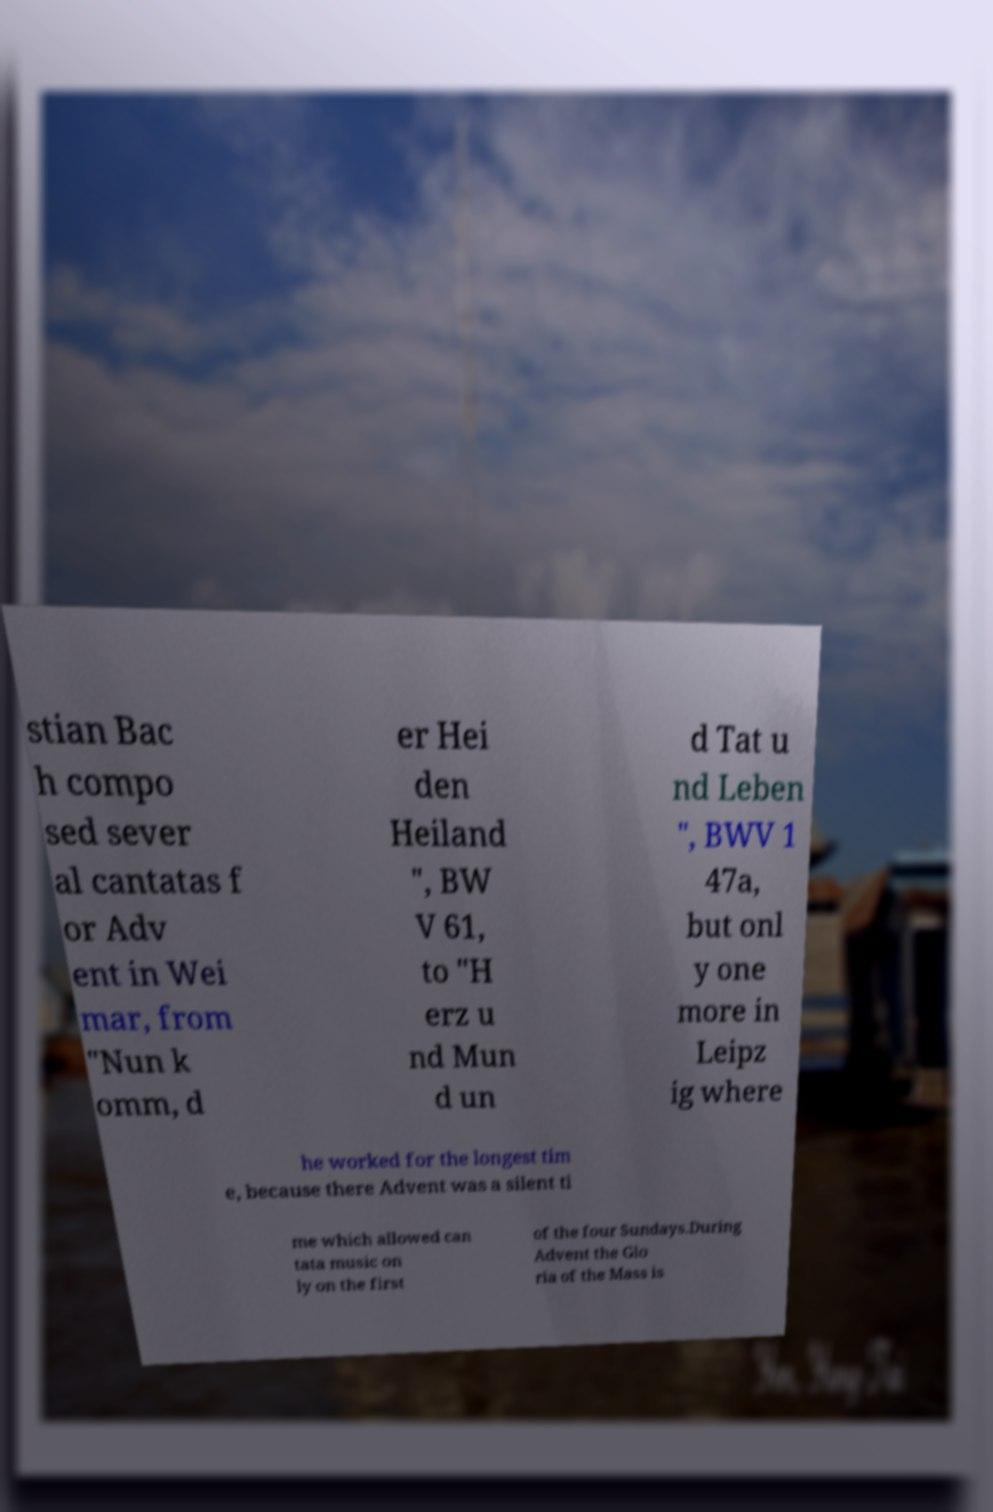Please read and relay the text visible in this image. What does it say? stian Bac h compo sed sever al cantatas f or Adv ent in Wei mar, from "Nun k omm, d er Hei den Heiland ", BW V 61, to "H erz u nd Mun d un d Tat u nd Leben ", BWV 1 47a, but onl y one more in Leipz ig where he worked for the longest tim e, because there Advent was a silent ti me which allowed can tata music on ly on the first of the four Sundays.During Advent the Glo ria of the Mass is 